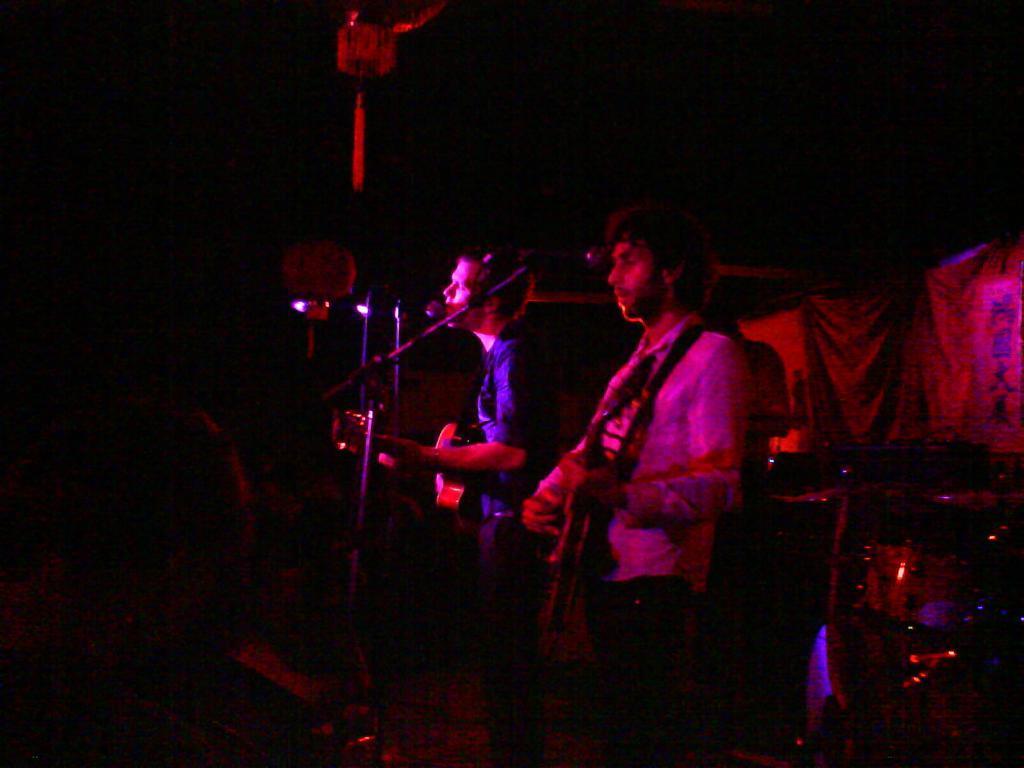In one or two sentences, can you explain what this image depicts? In this image there are few persons standing and holding guitar in their hand. Before them there are few mike stands. Behind them there are few musical instrument. Behind him there is a person. 